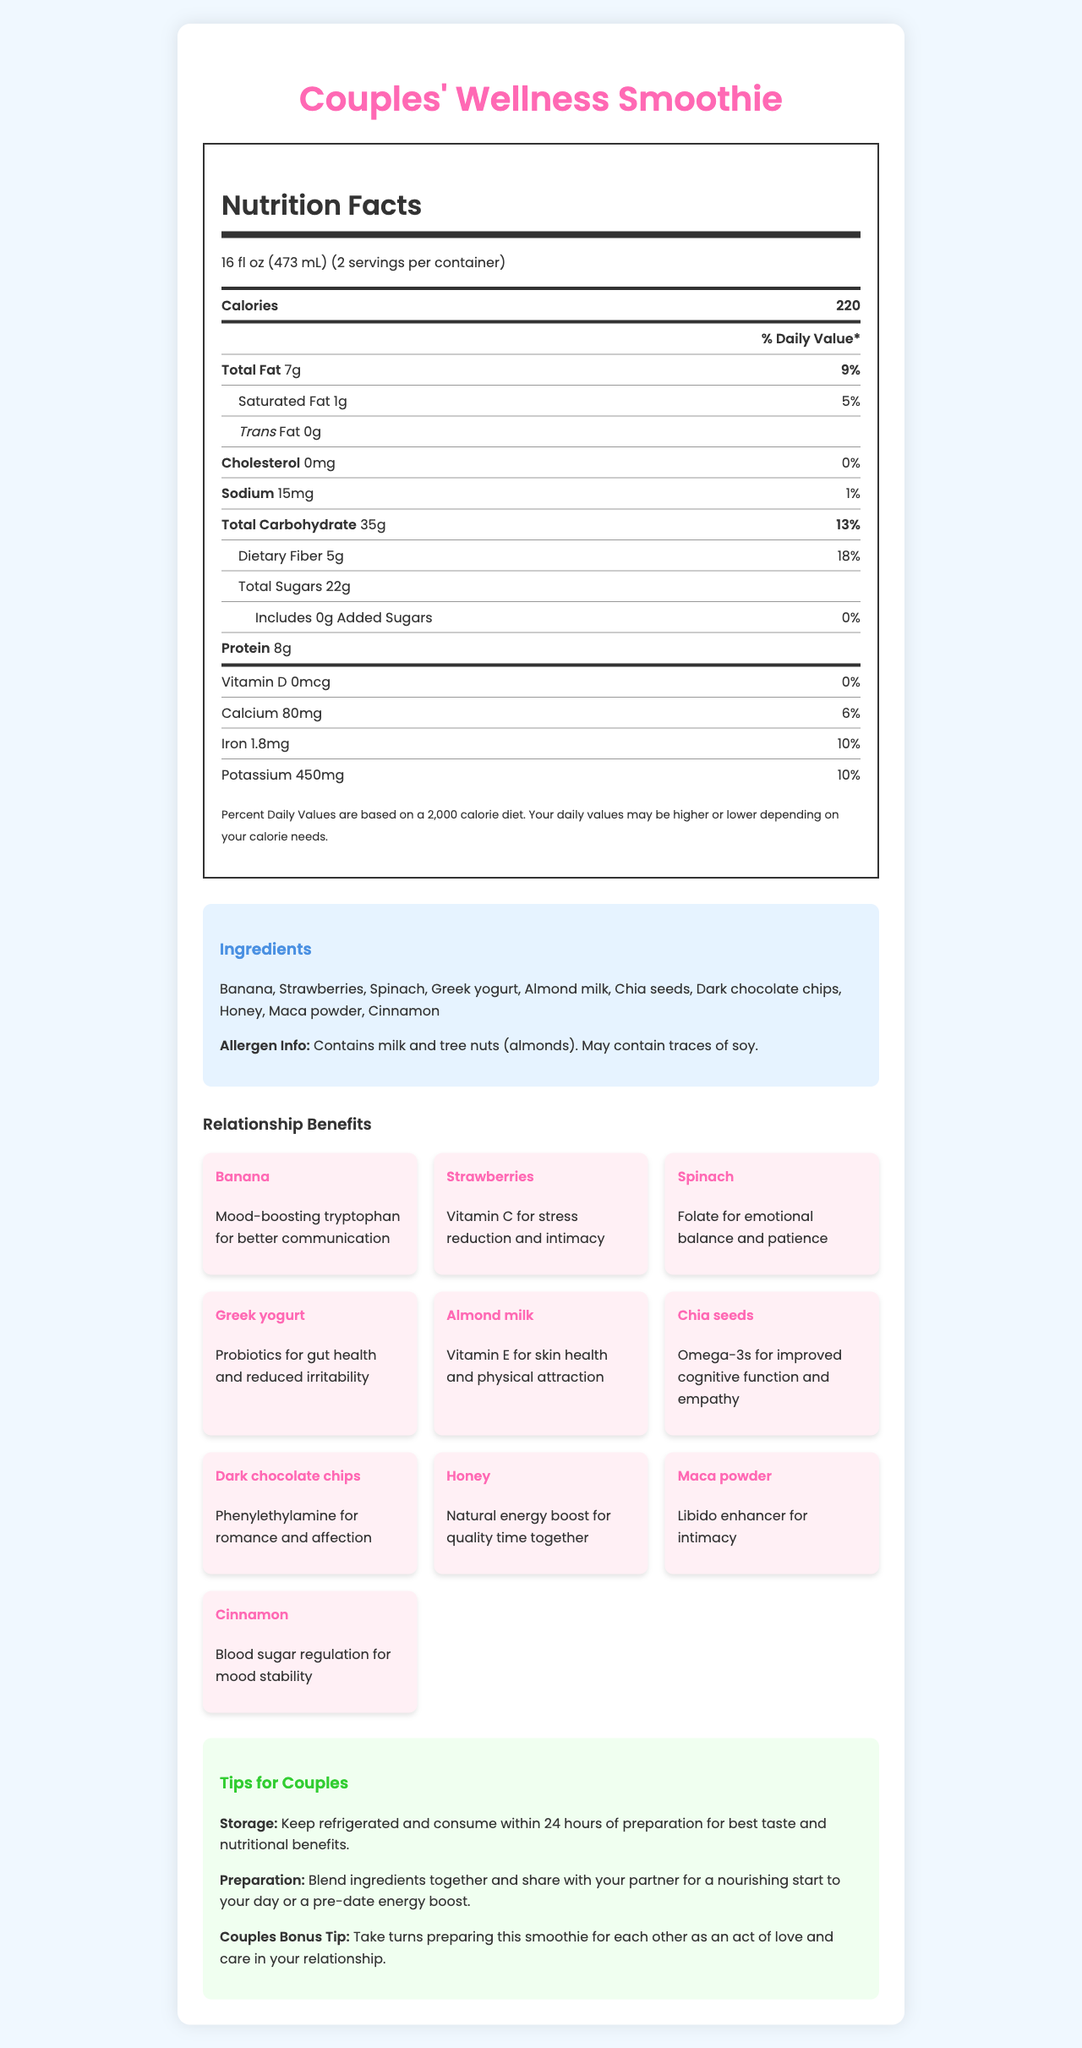what is the serving size of the Couples' Wellness Smoothie? The serving size is clearly stated in the document.
Answer: 16 fl oz (473 mL) how many calories are in one serving of the smoothie? The document indicates that there are 220 calories per serving.
Answer: 220 what are the main ingredients of the Couples' Wellness Smoothie? These ingredients are listed under the "Ingredients" section of the document.
Answer: Banana, Strawberries, Spinach, Greek yogurt, Almond milk, Chia seeds, Dark chocolate chips, Honey, Maca powder, Cinnamon how many grams of protein are in one serving? The document specifies that there are 8 grams of protein per serving.
Answer: 8g what is the percentage of the daily value for dietary fiber in one serving? The daily value percentage for dietary fiber is given as 18% in the document.
Answer: 18% what is the benefit of chia seeds in the smoothie? A. Improved Skin Health B. Improved Cognitive Function and Empathy C. Mood Stability The document lists Omega-3s for improved cognitive function and empathy as the benefit of chia seeds.
Answer: B. Improved Cognitive Function and Empathy which ingredient helps with mood stability? A. Almond milk B. Spinach C. Cinnamon D. Honey The document states that cinnamon helps with blood sugar regulation for mood stability.
Answer: C. Cinnamon does the smoothie contain any added sugars? The document indicates that there are 0 grams of added sugars.
Answer: No what should be done for best taste and nutritional benefits? The storage instructions specify to keep the smoothie refrigerated and consume it within 24 hours for best taste and nutritional benefits.
Answer: Keep refrigerated and consume within 24 hours of preparation can this smoothie help reduce stress? The document indicates that strawberries provide Vitamin C for stress reduction.
Answer: Yes describe the entire document briefly. The document presents a comprehensive overview of the nutritional content and health benefits of the Couples' Wellness Smoothie, emphasizing ingredients that boost both personal well-being and relationship health.
Answer: The document provides detailed nutritional information about the Couples' Wellness Smoothie, including serving size, calories, macro and micronutrients. It lists ingredients and their relationship benefits, such as mood-boosting, stress reduction, and intimacy enhancement. It also includes allergen information, storage instructions, preparation tips, and additional advice for couples to enhance their relationships. what is the total amount of cholesterol per serving? The document states that there is 0mg of cholesterol per serving.
Answer: 0mg what vitamin is provided by almond milk in the smoothie? The document states that almond milk provides Vitamin E for skin health and physical attraction.
Answer: Vitamin E how many servings are in one container? The document specifies that there are 2 servings per container.
Answer: 2 is it specified if the smoothie is gluten-free? The document does not provide information regarding whether the smoothie is gluten-free.
Answer: Not enough information what is the daily value percentage of iron provided by one serving? The document lists the daily value percentage of iron as 10%.
Answer: 10% which ingredient acts as a libido enhancer? The document states that maca powder is a libido enhancer for intimacy.
Answer: Maca powder 